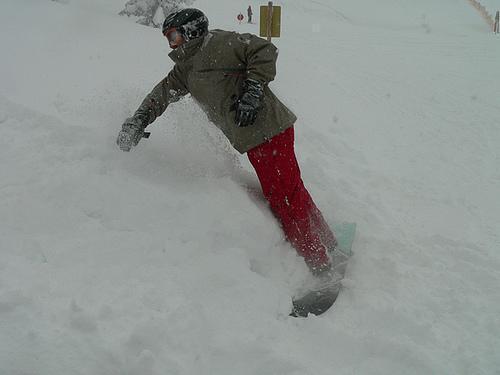Why is the person wearing a heavy jacket?
Select the accurate answer and provide explanation: 'Answer: answer
Rationale: rationale.'
Options: As cosplay, fashion, for work, cold weather. Answer: cold weather.
Rationale: The person is snowboarding, not working or cosplaying. the coat helps the person stay warm. 